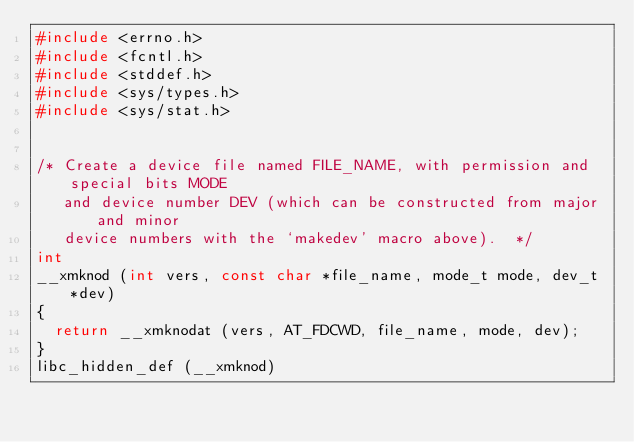Convert code to text. <code><loc_0><loc_0><loc_500><loc_500><_C_>#include <errno.h>
#include <fcntl.h>
#include <stddef.h>
#include <sys/types.h>
#include <sys/stat.h>


/* Create a device file named FILE_NAME, with permission and special bits MODE
   and device number DEV (which can be constructed from major and minor
   device numbers with the `makedev' macro above).  */
int
__xmknod (int vers, const char *file_name, mode_t mode, dev_t *dev)
{
  return __xmknodat (vers, AT_FDCWD, file_name, mode, dev);
}
libc_hidden_def (__xmknod)
</code> 